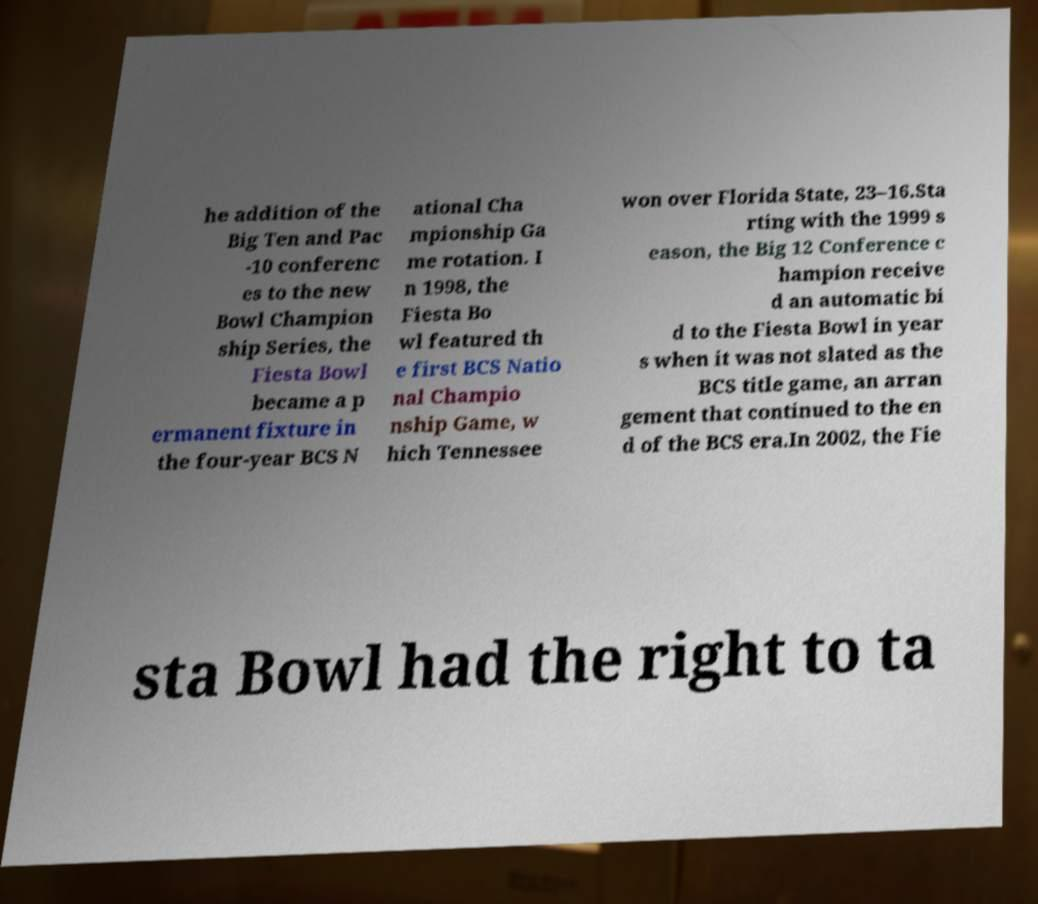There's text embedded in this image that I need extracted. Can you transcribe it verbatim? he addition of the Big Ten and Pac -10 conferenc es to the new Bowl Champion ship Series, the Fiesta Bowl became a p ermanent fixture in the four-year BCS N ational Cha mpionship Ga me rotation. I n 1998, the Fiesta Bo wl featured th e first BCS Natio nal Champio nship Game, w hich Tennessee won over Florida State, 23–16.Sta rting with the 1999 s eason, the Big 12 Conference c hampion receive d an automatic bi d to the Fiesta Bowl in year s when it was not slated as the BCS title game, an arran gement that continued to the en d of the BCS era.In 2002, the Fie sta Bowl had the right to ta 